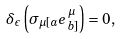Convert formula to latex. <formula><loc_0><loc_0><loc_500><loc_500>\delta _ { \epsilon } \left ( \sigma _ { \mu [ a } e _ { b ] } ^ { \, \mu } \right ) = 0 ,</formula> 